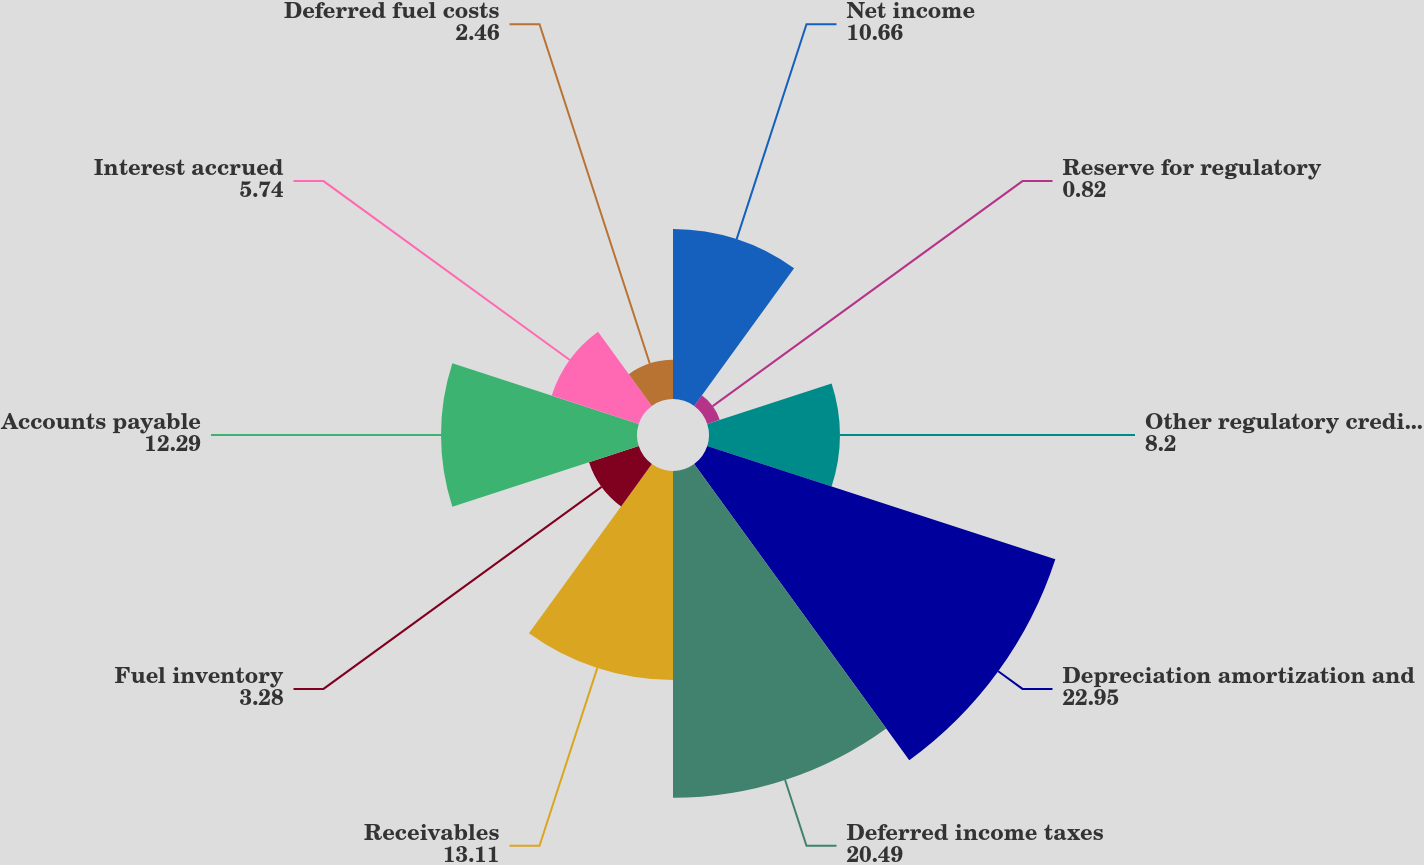<chart> <loc_0><loc_0><loc_500><loc_500><pie_chart><fcel>Net income<fcel>Reserve for regulatory<fcel>Other regulatory credits - net<fcel>Depreciation amortization and<fcel>Deferred income taxes<fcel>Receivables<fcel>Fuel inventory<fcel>Accounts payable<fcel>Interest accrued<fcel>Deferred fuel costs<nl><fcel>10.66%<fcel>0.82%<fcel>8.2%<fcel>22.95%<fcel>20.49%<fcel>13.11%<fcel>3.28%<fcel>12.29%<fcel>5.74%<fcel>2.46%<nl></chart> 